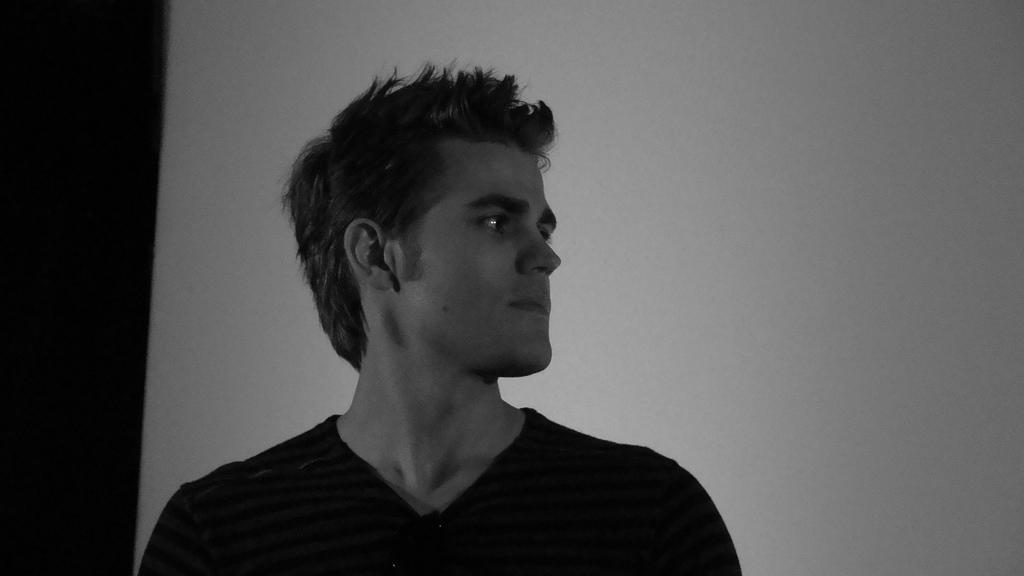Who or what is the main subject in the image? There is a person in the image. What is the person wearing? The person is wearing a dress. What is the color scheme of the image? The image is black and white. What type of cakes can be seen in the image? There are no cakes present in the image; it features a person wearing a dress in a black and white setting. 